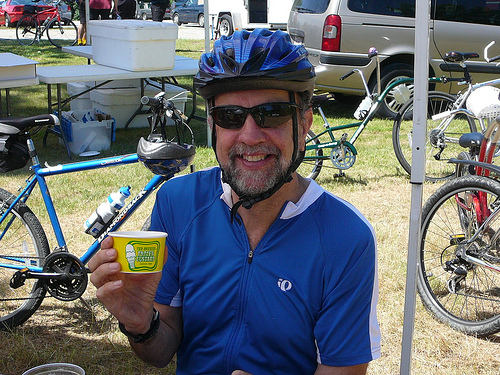Describe the person's attire in the photo. The person is dressed in typical cycling attire, which includes a blue cycling jersey, dark-colored shorts, sunglasses for eye protection, and a protective biking helmet. His outfit suggests an emphasis on comfort and safety while riding. 